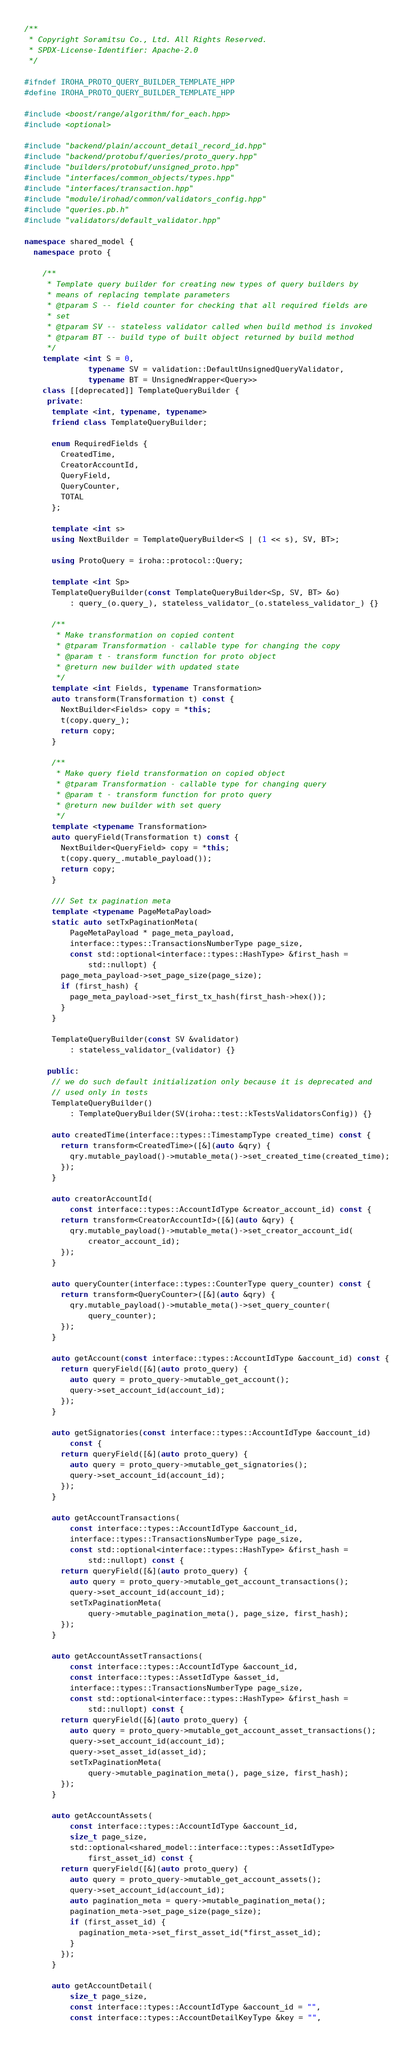<code> <loc_0><loc_0><loc_500><loc_500><_C++_>/**
 * Copyright Soramitsu Co., Ltd. All Rights Reserved.
 * SPDX-License-Identifier: Apache-2.0
 */

#ifndef IROHA_PROTO_QUERY_BUILDER_TEMPLATE_HPP
#define IROHA_PROTO_QUERY_BUILDER_TEMPLATE_HPP

#include <boost/range/algorithm/for_each.hpp>
#include <optional>

#include "backend/plain/account_detail_record_id.hpp"
#include "backend/protobuf/queries/proto_query.hpp"
#include "builders/protobuf/unsigned_proto.hpp"
#include "interfaces/common_objects/types.hpp"
#include "interfaces/transaction.hpp"
#include "module/irohad/common/validators_config.hpp"
#include "queries.pb.h"
#include "validators/default_validator.hpp"

namespace shared_model {
  namespace proto {

    /**
     * Template query builder for creating new types of query builders by
     * means of replacing template parameters
     * @tparam S -- field counter for checking that all required fields are
     * set
     * @tparam SV -- stateless validator called when build method is invoked
     * @tparam BT -- build type of built object returned by build method
     */
    template <int S = 0,
              typename SV = validation::DefaultUnsignedQueryValidator,
              typename BT = UnsignedWrapper<Query>>
    class [[deprecated]] TemplateQueryBuilder {
     private:
      template <int, typename, typename>
      friend class TemplateQueryBuilder;

      enum RequiredFields {
        CreatedTime,
        CreatorAccountId,
        QueryField,
        QueryCounter,
        TOTAL
      };

      template <int s>
      using NextBuilder = TemplateQueryBuilder<S | (1 << s), SV, BT>;

      using ProtoQuery = iroha::protocol::Query;

      template <int Sp>
      TemplateQueryBuilder(const TemplateQueryBuilder<Sp, SV, BT> &o)
          : query_(o.query_), stateless_validator_(o.stateless_validator_) {}

      /**
       * Make transformation on copied content
       * @tparam Transformation - callable type for changing the copy
       * @param t - transform function for proto object
       * @return new builder with updated state
       */
      template <int Fields, typename Transformation>
      auto transform(Transformation t) const {
        NextBuilder<Fields> copy = *this;
        t(copy.query_);
        return copy;
      }

      /**
       * Make query field transformation on copied object
       * @tparam Transformation - callable type for changing query
       * @param t - transform function for proto query
       * @return new builder with set query
       */
      template <typename Transformation>
      auto queryField(Transformation t) const {
        NextBuilder<QueryField> copy = *this;
        t(copy.query_.mutable_payload());
        return copy;
      }

      /// Set tx pagination meta
      template <typename PageMetaPayload>
      static auto setTxPaginationMeta(
          PageMetaPayload * page_meta_payload,
          interface::types::TransactionsNumberType page_size,
          const std::optional<interface::types::HashType> &first_hash =
              std::nullopt) {
        page_meta_payload->set_page_size(page_size);
        if (first_hash) {
          page_meta_payload->set_first_tx_hash(first_hash->hex());
        }
      }

      TemplateQueryBuilder(const SV &validator)
          : stateless_validator_(validator) {}

     public:
      // we do such default initialization only because it is deprecated and
      // used only in tests
      TemplateQueryBuilder()
          : TemplateQueryBuilder(SV(iroha::test::kTestsValidatorsConfig)) {}

      auto createdTime(interface::types::TimestampType created_time) const {
        return transform<CreatedTime>([&](auto &qry) {
          qry.mutable_payload()->mutable_meta()->set_created_time(created_time);
        });
      }

      auto creatorAccountId(
          const interface::types::AccountIdType &creator_account_id) const {
        return transform<CreatorAccountId>([&](auto &qry) {
          qry.mutable_payload()->mutable_meta()->set_creator_account_id(
              creator_account_id);
        });
      }

      auto queryCounter(interface::types::CounterType query_counter) const {
        return transform<QueryCounter>([&](auto &qry) {
          qry.mutable_payload()->mutable_meta()->set_query_counter(
              query_counter);
        });
      }

      auto getAccount(const interface::types::AccountIdType &account_id) const {
        return queryField([&](auto proto_query) {
          auto query = proto_query->mutable_get_account();
          query->set_account_id(account_id);
        });
      }

      auto getSignatories(const interface::types::AccountIdType &account_id)
          const {
        return queryField([&](auto proto_query) {
          auto query = proto_query->mutable_get_signatories();
          query->set_account_id(account_id);
        });
      }

      auto getAccountTransactions(
          const interface::types::AccountIdType &account_id,
          interface::types::TransactionsNumberType page_size,
          const std::optional<interface::types::HashType> &first_hash =
              std::nullopt) const {
        return queryField([&](auto proto_query) {
          auto query = proto_query->mutable_get_account_transactions();
          query->set_account_id(account_id);
          setTxPaginationMeta(
              query->mutable_pagination_meta(), page_size, first_hash);
        });
      }

      auto getAccountAssetTransactions(
          const interface::types::AccountIdType &account_id,
          const interface::types::AssetIdType &asset_id,
          interface::types::TransactionsNumberType page_size,
          const std::optional<interface::types::HashType> &first_hash =
              std::nullopt) const {
        return queryField([&](auto proto_query) {
          auto query = proto_query->mutable_get_account_asset_transactions();
          query->set_account_id(account_id);
          query->set_asset_id(asset_id);
          setTxPaginationMeta(
              query->mutable_pagination_meta(), page_size, first_hash);
        });
      }

      auto getAccountAssets(
          const interface::types::AccountIdType &account_id,
          size_t page_size,
          std::optional<shared_model::interface::types::AssetIdType>
              first_asset_id) const {
        return queryField([&](auto proto_query) {
          auto query = proto_query->mutable_get_account_assets();
          query->set_account_id(account_id);
          auto pagination_meta = query->mutable_pagination_meta();
          pagination_meta->set_page_size(page_size);
          if (first_asset_id) {
            pagination_meta->set_first_asset_id(*first_asset_id);
          }
        });
      }

      auto getAccountDetail(
          size_t page_size,
          const interface::types::AccountIdType &account_id = "",
          const interface::types::AccountDetailKeyType &key = "",</code> 